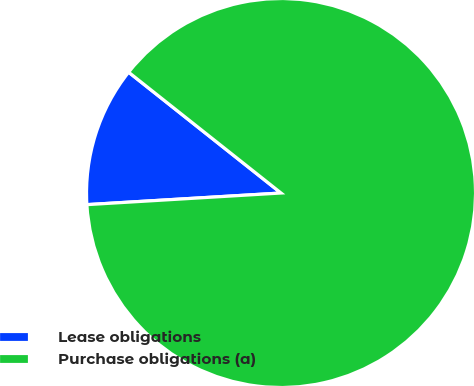<chart> <loc_0><loc_0><loc_500><loc_500><pie_chart><fcel>Lease obligations<fcel>Purchase obligations (a)<nl><fcel>11.62%<fcel>88.38%<nl></chart> 